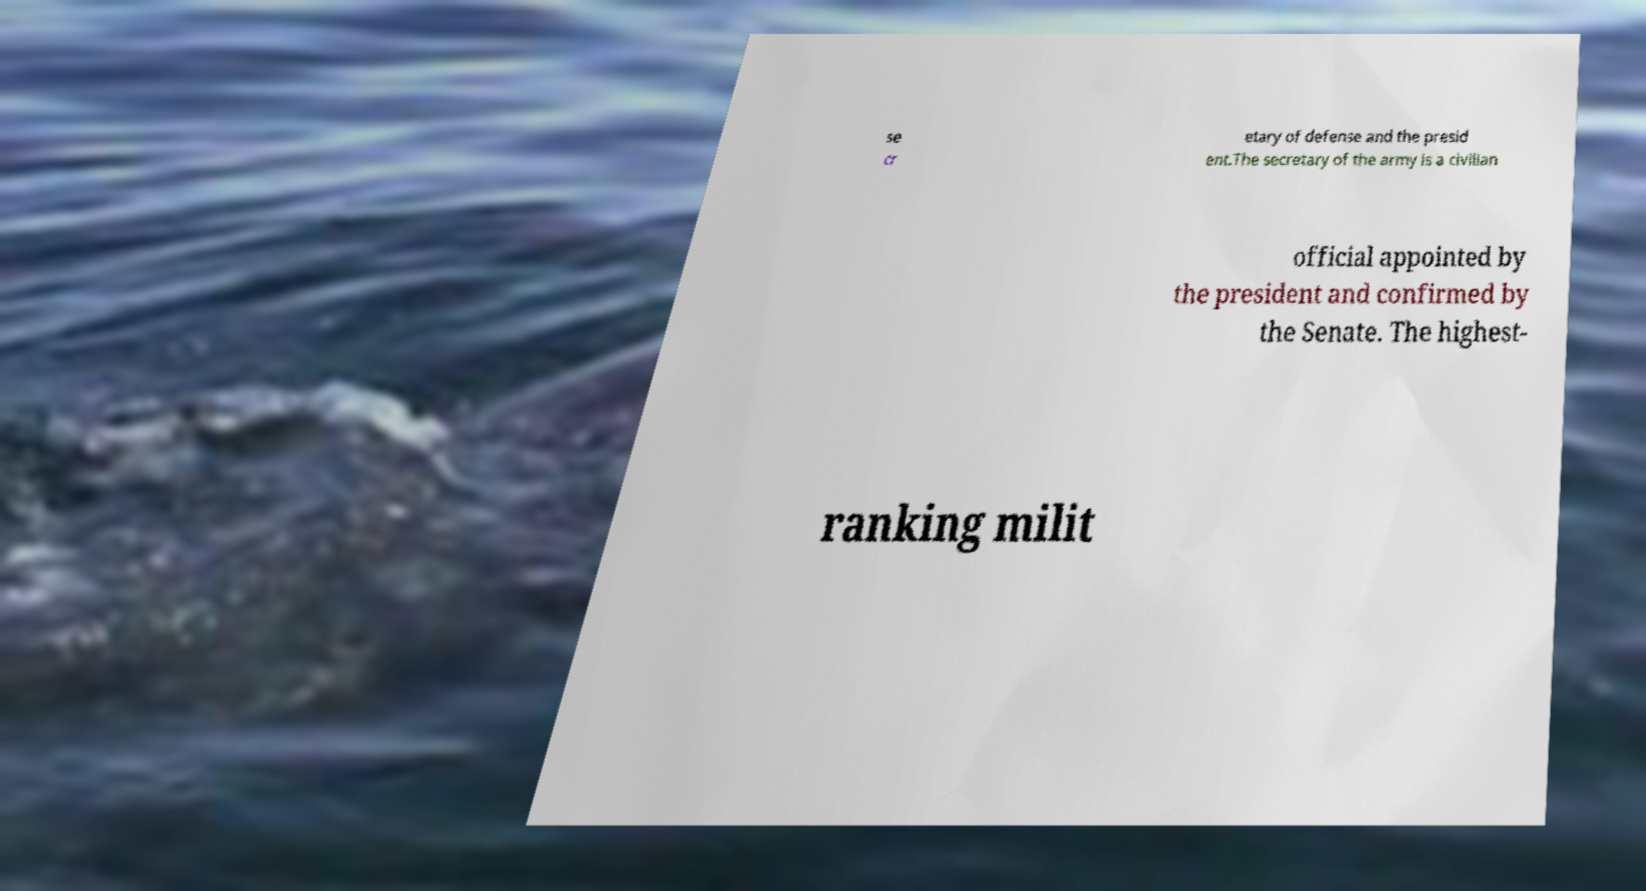Please read and relay the text visible in this image. What does it say? se cr etary of defense and the presid ent.The secretary of the army is a civilian official appointed by the president and confirmed by the Senate. The highest- ranking milit 